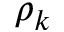<formula> <loc_0><loc_0><loc_500><loc_500>\rho _ { k }</formula> 